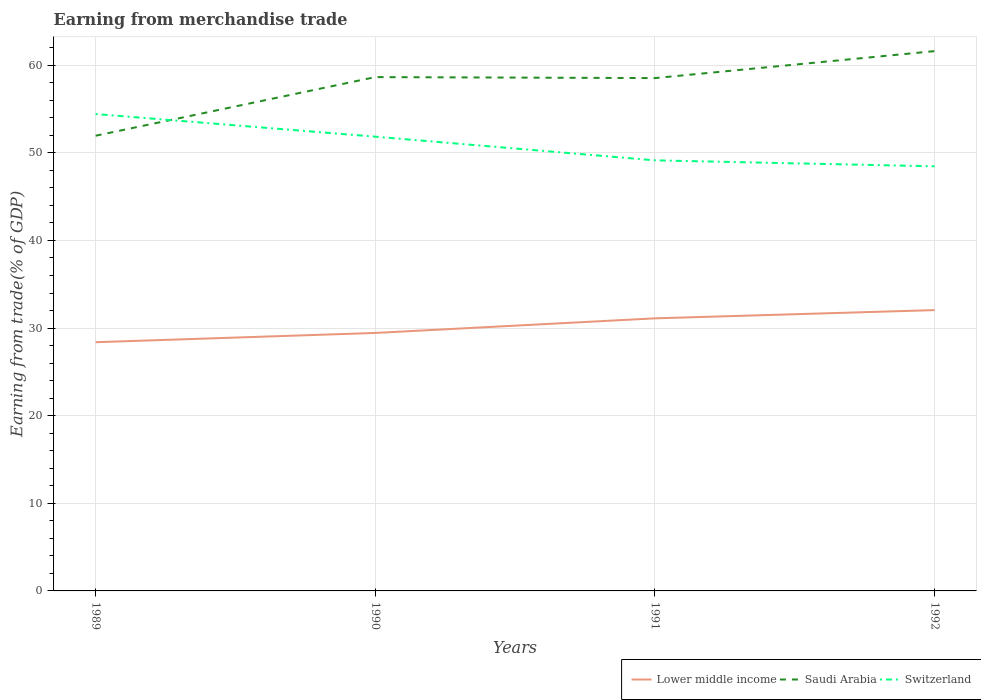Does the line corresponding to Saudi Arabia intersect with the line corresponding to Lower middle income?
Offer a terse response. No. Is the number of lines equal to the number of legend labels?
Offer a very short reply. Yes. Across all years, what is the maximum earnings from trade in Lower middle income?
Ensure brevity in your answer.  28.39. In which year was the earnings from trade in Switzerland maximum?
Your response must be concise. 1992. What is the total earnings from trade in Switzerland in the graph?
Give a very brief answer. 5.29. What is the difference between the highest and the second highest earnings from trade in Lower middle income?
Offer a very short reply. 3.66. What is the difference between the highest and the lowest earnings from trade in Saudi Arabia?
Keep it short and to the point. 3. Is the earnings from trade in Lower middle income strictly greater than the earnings from trade in Saudi Arabia over the years?
Make the answer very short. Yes. Does the graph contain grids?
Your answer should be compact. Yes. Where does the legend appear in the graph?
Make the answer very short. Bottom right. How many legend labels are there?
Your answer should be very brief. 3. What is the title of the graph?
Your response must be concise. Earning from merchandise trade. Does "United Kingdom" appear as one of the legend labels in the graph?
Provide a short and direct response. No. What is the label or title of the X-axis?
Make the answer very short. Years. What is the label or title of the Y-axis?
Provide a succinct answer. Earning from trade(% of GDP). What is the Earning from trade(% of GDP) in Lower middle income in 1989?
Keep it short and to the point. 28.39. What is the Earning from trade(% of GDP) of Saudi Arabia in 1989?
Give a very brief answer. 51.95. What is the Earning from trade(% of GDP) in Switzerland in 1989?
Offer a terse response. 54.43. What is the Earning from trade(% of GDP) of Lower middle income in 1990?
Give a very brief answer. 29.44. What is the Earning from trade(% of GDP) in Saudi Arabia in 1990?
Make the answer very short. 58.65. What is the Earning from trade(% of GDP) of Switzerland in 1990?
Keep it short and to the point. 51.85. What is the Earning from trade(% of GDP) in Lower middle income in 1991?
Your answer should be very brief. 31.11. What is the Earning from trade(% of GDP) in Saudi Arabia in 1991?
Offer a terse response. 58.53. What is the Earning from trade(% of GDP) in Switzerland in 1991?
Offer a terse response. 49.14. What is the Earning from trade(% of GDP) in Lower middle income in 1992?
Provide a short and direct response. 32.05. What is the Earning from trade(% of GDP) in Saudi Arabia in 1992?
Provide a succinct answer. 61.61. What is the Earning from trade(% of GDP) in Switzerland in 1992?
Provide a succinct answer. 48.46. Across all years, what is the maximum Earning from trade(% of GDP) of Lower middle income?
Provide a succinct answer. 32.05. Across all years, what is the maximum Earning from trade(% of GDP) of Saudi Arabia?
Keep it short and to the point. 61.61. Across all years, what is the maximum Earning from trade(% of GDP) of Switzerland?
Your answer should be compact. 54.43. Across all years, what is the minimum Earning from trade(% of GDP) in Lower middle income?
Offer a very short reply. 28.39. Across all years, what is the minimum Earning from trade(% of GDP) in Saudi Arabia?
Your answer should be compact. 51.95. Across all years, what is the minimum Earning from trade(% of GDP) in Switzerland?
Keep it short and to the point. 48.46. What is the total Earning from trade(% of GDP) of Lower middle income in the graph?
Your answer should be very brief. 121. What is the total Earning from trade(% of GDP) of Saudi Arabia in the graph?
Provide a short and direct response. 230.75. What is the total Earning from trade(% of GDP) of Switzerland in the graph?
Provide a short and direct response. 203.89. What is the difference between the Earning from trade(% of GDP) of Lower middle income in 1989 and that in 1990?
Your answer should be compact. -1.06. What is the difference between the Earning from trade(% of GDP) of Saudi Arabia in 1989 and that in 1990?
Offer a terse response. -6.69. What is the difference between the Earning from trade(% of GDP) of Switzerland in 1989 and that in 1990?
Offer a terse response. 2.58. What is the difference between the Earning from trade(% of GDP) in Lower middle income in 1989 and that in 1991?
Your response must be concise. -2.72. What is the difference between the Earning from trade(% of GDP) in Saudi Arabia in 1989 and that in 1991?
Offer a terse response. -6.58. What is the difference between the Earning from trade(% of GDP) in Switzerland in 1989 and that in 1991?
Make the answer very short. 5.29. What is the difference between the Earning from trade(% of GDP) in Lower middle income in 1989 and that in 1992?
Offer a terse response. -3.66. What is the difference between the Earning from trade(% of GDP) of Saudi Arabia in 1989 and that in 1992?
Your answer should be very brief. -9.66. What is the difference between the Earning from trade(% of GDP) of Switzerland in 1989 and that in 1992?
Provide a short and direct response. 5.97. What is the difference between the Earning from trade(% of GDP) in Lower middle income in 1990 and that in 1991?
Offer a terse response. -1.67. What is the difference between the Earning from trade(% of GDP) of Saudi Arabia in 1990 and that in 1991?
Offer a terse response. 0.11. What is the difference between the Earning from trade(% of GDP) in Switzerland in 1990 and that in 1991?
Provide a short and direct response. 2.7. What is the difference between the Earning from trade(% of GDP) in Lower middle income in 1990 and that in 1992?
Ensure brevity in your answer.  -2.61. What is the difference between the Earning from trade(% of GDP) of Saudi Arabia in 1990 and that in 1992?
Offer a terse response. -2.96. What is the difference between the Earning from trade(% of GDP) of Switzerland in 1990 and that in 1992?
Make the answer very short. 3.38. What is the difference between the Earning from trade(% of GDP) in Lower middle income in 1991 and that in 1992?
Offer a very short reply. -0.94. What is the difference between the Earning from trade(% of GDP) in Saudi Arabia in 1991 and that in 1992?
Your answer should be very brief. -3.08. What is the difference between the Earning from trade(% of GDP) of Switzerland in 1991 and that in 1992?
Ensure brevity in your answer.  0.68. What is the difference between the Earning from trade(% of GDP) of Lower middle income in 1989 and the Earning from trade(% of GDP) of Saudi Arabia in 1990?
Provide a succinct answer. -30.26. What is the difference between the Earning from trade(% of GDP) in Lower middle income in 1989 and the Earning from trade(% of GDP) in Switzerland in 1990?
Offer a very short reply. -23.46. What is the difference between the Earning from trade(% of GDP) of Saudi Arabia in 1989 and the Earning from trade(% of GDP) of Switzerland in 1990?
Provide a succinct answer. 0.11. What is the difference between the Earning from trade(% of GDP) in Lower middle income in 1989 and the Earning from trade(% of GDP) in Saudi Arabia in 1991?
Provide a short and direct response. -30.15. What is the difference between the Earning from trade(% of GDP) of Lower middle income in 1989 and the Earning from trade(% of GDP) of Switzerland in 1991?
Offer a terse response. -20.76. What is the difference between the Earning from trade(% of GDP) in Saudi Arabia in 1989 and the Earning from trade(% of GDP) in Switzerland in 1991?
Make the answer very short. 2.81. What is the difference between the Earning from trade(% of GDP) of Lower middle income in 1989 and the Earning from trade(% of GDP) of Saudi Arabia in 1992?
Provide a succinct answer. -33.22. What is the difference between the Earning from trade(% of GDP) of Lower middle income in 1989 and the Earning from trade(% of GDP) of Switzerland in 1992?
Provide a succinct answer. -20.08. What is the difference between the Earning from trade(% of GDP) in Saudi Arabia in 1989 and the Earning from trade(% of GDP) in Switzerland in 1992?
Your response must be concise. 3.49. What is the difference between the Earning from trade(% of GDP) of Lower middle income in 1990 and the Earning from trade(% of GDP) of Saudi Arabia in 1991?
Make the answer very short. -29.09. What is the difference between the Earning from trade(% of GDP) in Lower middle income in 1990 and the Earning from trade(% of GDP) in Switzerland in 1991?
Offer a very short reply. -19.7. What is the difference between the Earning from trade(% of GDP) in Saudi Arabia in 1990 and the Earning from trade(% of GDP) in Switzerland in 1991?
Offer a terse response. 9.5. What is the difference between the Earning from trade(% of GDP) in Lower middle income in 1990 and the Earning from trade(% of GDP) in Saudi Arabia in 1992?
Your answer should be very brief. -32.17. What is the difference between the Earning from trade(% of GDP) of Lower middle income in 1990 and the Earning from trade(% of GDP) of Switzerland in 1992?
Make the answer very short. -19.02. What is the difference between the Earning from trade(% of GDP) in Saudi Arabia in 1990 and the Earning from trade(% of GDP) in Switzerland in 1992?
Offer a terse response. 10.18. What is the difference between the Earning from trade(% of GDP) of Lower middle income in 1991 and the Earning from trade(% of GDP) of Saudi Arabia in 1992?
Give a very brief answer. -30.5. What is the difference between the Earning from trade(% of GDP) of Lower middle income in 1991 and the Earning from trade(% of GDP) of Switzerland in 1992?
Give a very brief answer. -17.35. What is the difference between the Earning from trade(% of GDP) of Saudi Arabia in 1991 and the Earning from trade(% of GDP) of Switzerland in 1992?
Keep it short and to the point. 10.07. What is the average Earning from trade(% of GDP) of Lower middle income per year?
Give a very brief answer. 30.25. What is the average Earning from trade(% of GDP) of Saudi Arabia per year?
Keep it short and to the point. 57.69. What is the average Earning from trade(% of GDP) in Switzerland per year?
Provide a short and direct response. 50.97. In the year 1989, what is the difference between the Earning from trade(% of GDP) of Lower middle income and Earning from trade(% of GDP) of Saudi Arabia?
Offer a terse response. -23.57. In the year 1989, what is the difference between the Earning from trade(% of GDP) of Lower middle income and Earning from trade(% of GDP) of Switzerland?
Offer a terse response. -26.04. In the year 1989, what is the difference between the Earning from trade(% of GDP) of Saudi Arabia and Earning from trade(% of GDP) of Switzerland?
Provide a succinct answer. -2.48. In the year 1990, what is the difference between the Earning from trade(% of GDP) of Lower middle income and Earning from trade(% of GDP) of Saudi Arabia?
Offer a terse response. -29.2. In the year 1990, what is the difference between the Earning from trade(% of GDP) in Lower middle income and Earning from trade(% of GDP) in Switzerland?
Keep it short and to the point. -22.4. In the year 1990, what is the difference between the Earning from trade(% of GDP) of Saudi Arabia and Earning from trade(% of GDP) of Switzerland?
Provide a short and direct response. 6.8. In the year 1991, what is the difference between the Earning from trade(% of GDP) of Lower middle income and Earning from trade(% of GDP) of Saudi Arabia?
Provide a succinct answer. -27.42. In the year 1991, what is the difference between the Earning from trade(% of GDP) of Lower middle income and Earning from trade(% of GDP) of Switzerland?
Offer a terse response. -18.03. In the year 1991, what is the difference between the Earning from trade(% of GDP) in Saudi Arabia and Earning from trade(% of GDP) in Switzerland?
Make the answer very short. 9.39. In the year 1992, what is the difference between the Earning from trade(% of GDP) of Lower middle income and Earning from trade(% of GDP) of Saudi Arabia?
Provide a succinct answer. -29.56. In the year 1992, what is the difference between the Earning from trade(% of GDP) in Lower middle income and Earning from trade(% of GDP) in Switzerland?
Offer a terse response. -16.41. In the year 1992, what is the difference between the Earning from trade(% of GDP) in Saudi Arabia and Earning from trade(% of GDP) in Switzerland?
Keep it short and to the point. 13.15. What is the ratio of the Earning from trade(% of GDP) in Lower middle income in 1989 to that in 1990?
Keep it short and to the point. 0.96. What is the ratio of the Earning from trade(% of GDP) of Saudi Arabia in 1989 to that in 1990?
Your response must be concise. 0.89. What is the ratio of the Earning from trade(% of GDP) of Switzerland in 1989 to that in 1990?
Make the answer very short. 1.05. What is the ratio of the Earning from trade(% of GDP) of Lower middle income in 1989 to that in 1991?
Give a very brief answer. 0.91. What is the ratio of the Earning from trade(% of GDP) of Saudi Arabia in 1989 to that in 1991?
Your answer should be compact. 0.89. What is the ratio of the Earning from trade(% of GDP) of Switzerland in 1989 to that in 1991?
Make the answer very short. 1.11. What is the ratio of the Earning from trade(% of GDP) of Lower middle income in 1989 to that in 1992?
Your response must be concise. 0.89. What is the ratio of the Earning from trade(% of GDP) in Saudi Arabia in 1989 to that in 1992?
Ensure brevity in your answer.  0.84. What is the ratio of the Earning from trade(% of GDP) in Switzerland in 1989 to that in 1992?
Keep it short and to the point. 1.12. What is the ratio of the Earning from trade(% of GDP) of Lower middle income in 1990 to that in 1991?
Give a very brief answer. 0.95. What is the ratio of the Earning from trade(% of GDP) in Switzerland in 1990 to that in 1991?
Your response must be concise. 1.05. What is the ratio of the Earning from trade(% of GDP) in Lower middle income in 1990 to that in 1992?
Provide a succinct answer. 0.92. What is the ratio of the Earning from trade(% of GDP) in Saudi Arabia in 1990 to that in 1992?
Offer a very short reply. 0.95. What is the ratio of the Earning from trade(% of GDP) of Switzerland in 1990 to that in 1992?
Provide a succinct answer. 1.07. What is the ratio of the Earning from trade(% of GDP) in Lower middle income in 1991 to that in 1992?
Your answer should be very brief. 0.97. What is the ratio of the Earning from trade(% of GDP) in Saudi Arabia in 1991 to that in 1992?
Your answer should be compact. 0.95. What is the ratio of the Earning from trade(% of GDP) in Switzerland in 1991 to that in 1992?
Make the answer very short. 1.01. What is the difference between the highest and the second highest Earning from trade(% of GDP) of Lower middle income?
Ensure brevity in your answer.  0.94. What is the difference between the highest and the second highest Earning from trade(% of GDP) in Saudi Arabia?
Ensure brevity in your answer.  2.96. What is the difference between the highest and the second highest Earning from trade(% of GDP) in Switzerland?
Keep it short and to the point. 2.58. What is the difference between the highest and the lowest Earning from trade(% of GDP) of Lower middle income?
Give a very brief answer. 3.66. What is the difference between the highest and the lowest Earning from trade(% of GDP) in Saudi Arabia?
Your response must be concise. 9.66. What is the difference between the highest and the lowest Earning from trade(% of GDP) in Switzerland?
Provide a short and direct response. 5.97. 